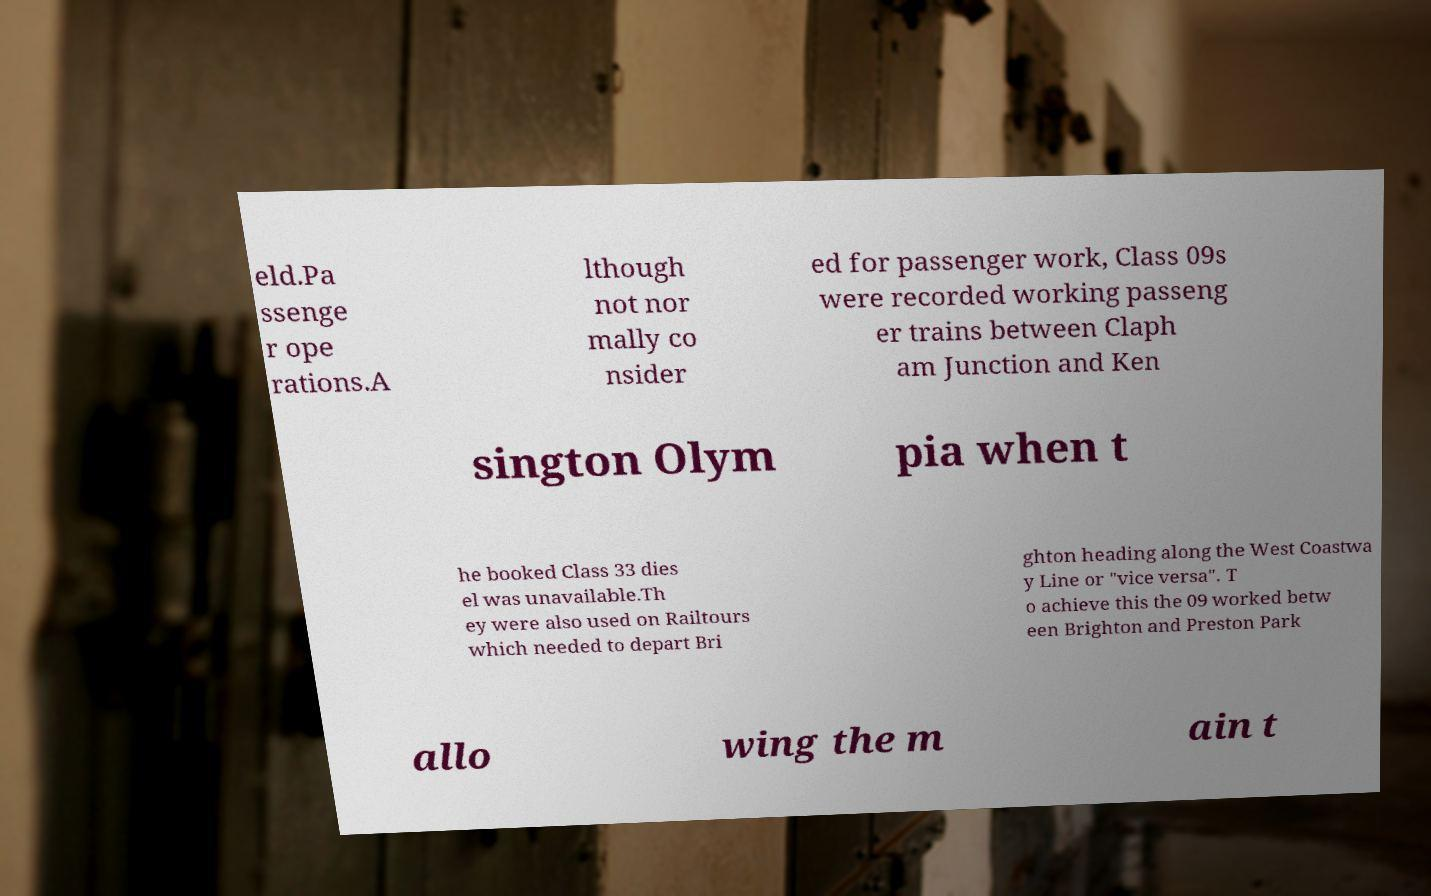There's text embedded in this image that I need extracted. Can you transcribe it verbatim? eld.Pa ssenge r ope rations.A lthough not nor mally co nsider ed for passenger work, Class 09s were recorded working passeng er trains between Claph am Junction and Ken sington Olym pia when t he booked Class 33 dies el was unavailable.Th ey were also used on Railtours which needed to depart Bri ghton heading along the West Coastwa y Line or "vice versa". T o achieve this the 09 worked betw een Brighton and Preston Park allo wing the m ain t 